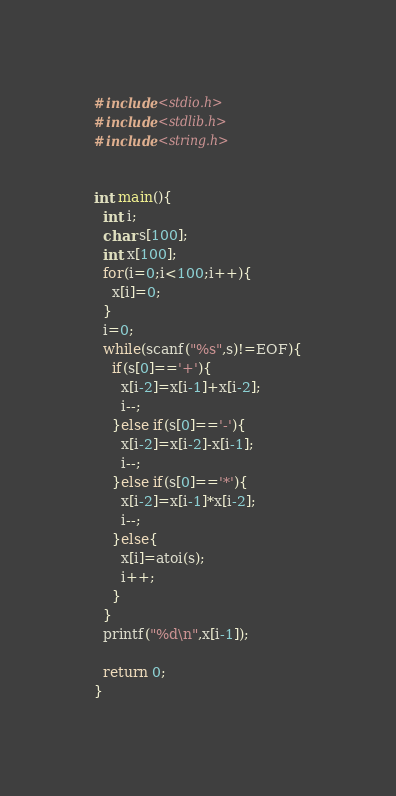Convert code to text. <code><loc_0><loc_0><loc_500><loc_500><_C_>#include<stdio.h>
#include<stdlib.h>
#include<string.h>


int main(){
  int i;
  char s[100];
  int x[100];
  for(i=0;i<100;i++){
    x[i]=0;
  }
  i=0;
  while(scanf("%s",s)!=EOF){
    if(s[0]=='+'){
      x[i-2]=x[i-1]+x[i-2];
      i--;
    }else if(s[0]=='-'){
      x[i-2]=x[i-2]-x[i-1];
      i--;
    }else if(s[0]=='*'){
      x[i-2]=x[i-1]*x[i-2];
      i--;
    }else{
      x[i]=atoi(s);
      i++;
    }
  }
  printf("%d\n",x[i-1]);

  return 0;
}</code> 